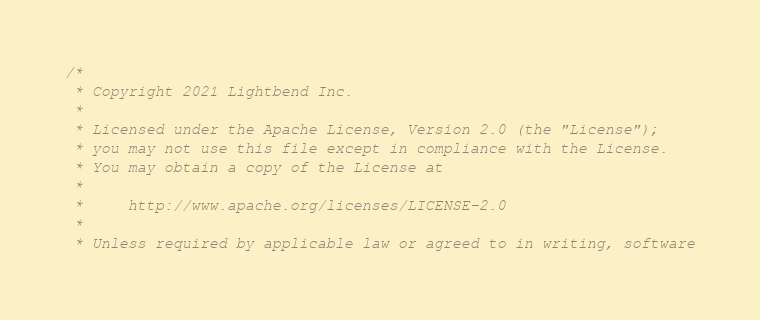<code> <loc_0><loc_0><loc_500><loc_500><_Scala_>/*
 * Copyright 2021 Lightbend Inc.
 *
 * Licensed under the Apache License, Version 2.0 (the "License");
 * you may not use this file except in compliance with the License.
 * You may obtain a copy of the License at
 *
 *     http://www.apache.org/licenses/LICENSE-2.0
 *
 * Unless required by applicable law or agreed to in writing, software</code> 